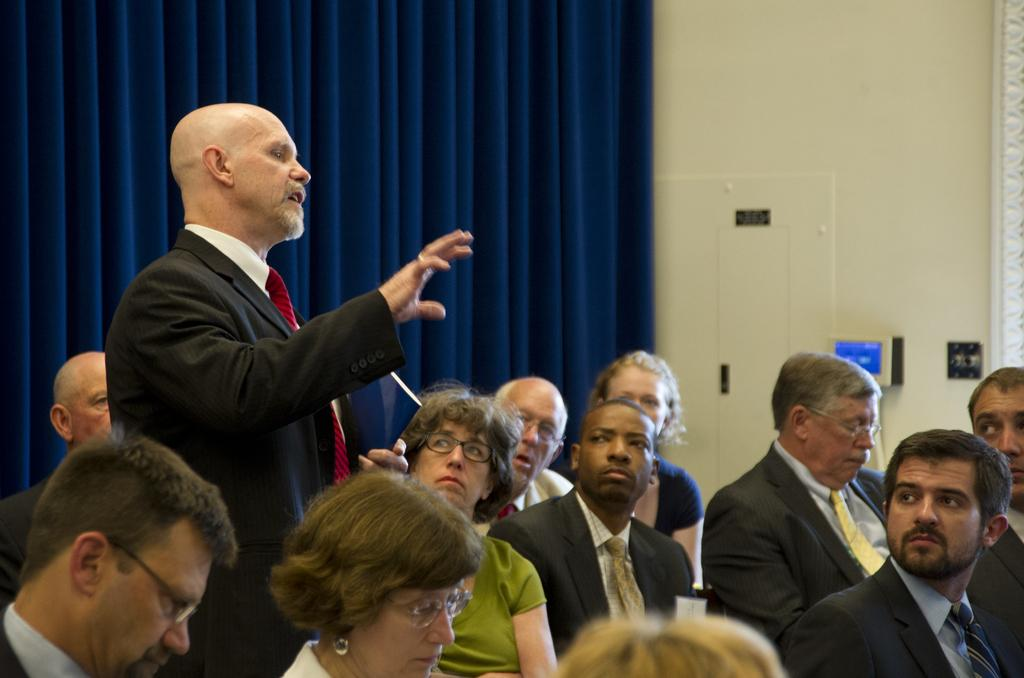What are the people in the image doing? The people in the image are sitting. Is there anyone standing in the image? Yes, there is a person standing in the image. What can be seen in the background or surrounding the people? There is a curtain visible in the image. How many frogs are sitting on the clock in the image? There is no clock or frogs present in the image. What type of structure is visible in the background of the image? The provided facts do not mention any specific structure in the background of the image. 